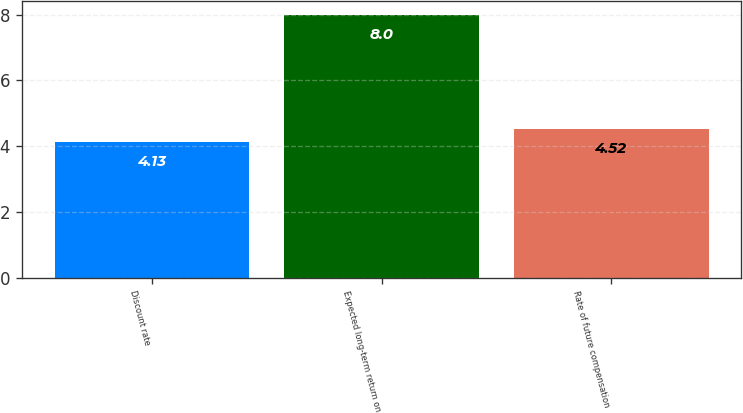<chart> <loc_0><loc_0><loc_500><loc_500><bar_chart><fcel>Discount rate<fcel>Expected long-term return on<fcel>Rate of future compensation<nl><fcel>4.13<fcel>8<fcel>4.52<nl></chart> 